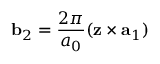<formula> <loc_0><loc_0><loc_500><loc_500>{ b } _ { 2 } = \frac { 2 \pi } { a _ { 0 } } ( { z } \times { a } _ { 1 } )</formula> 